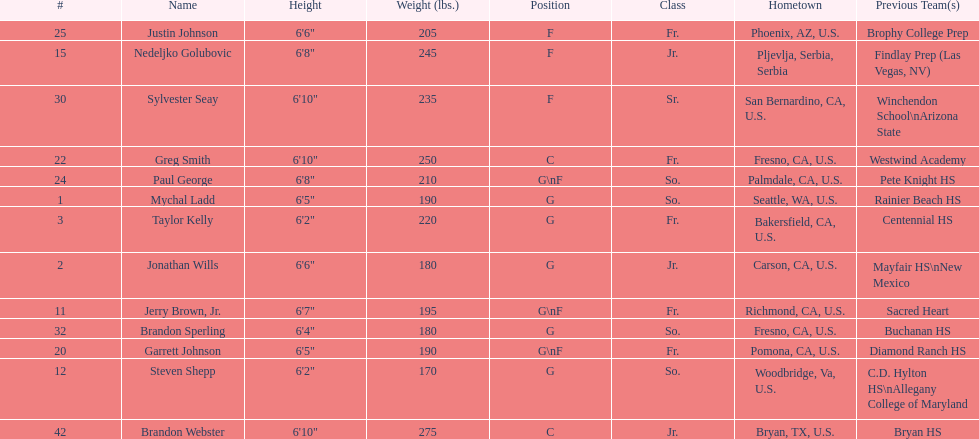Which player previously played for sacred heart? Jerry Brown, Jr. 